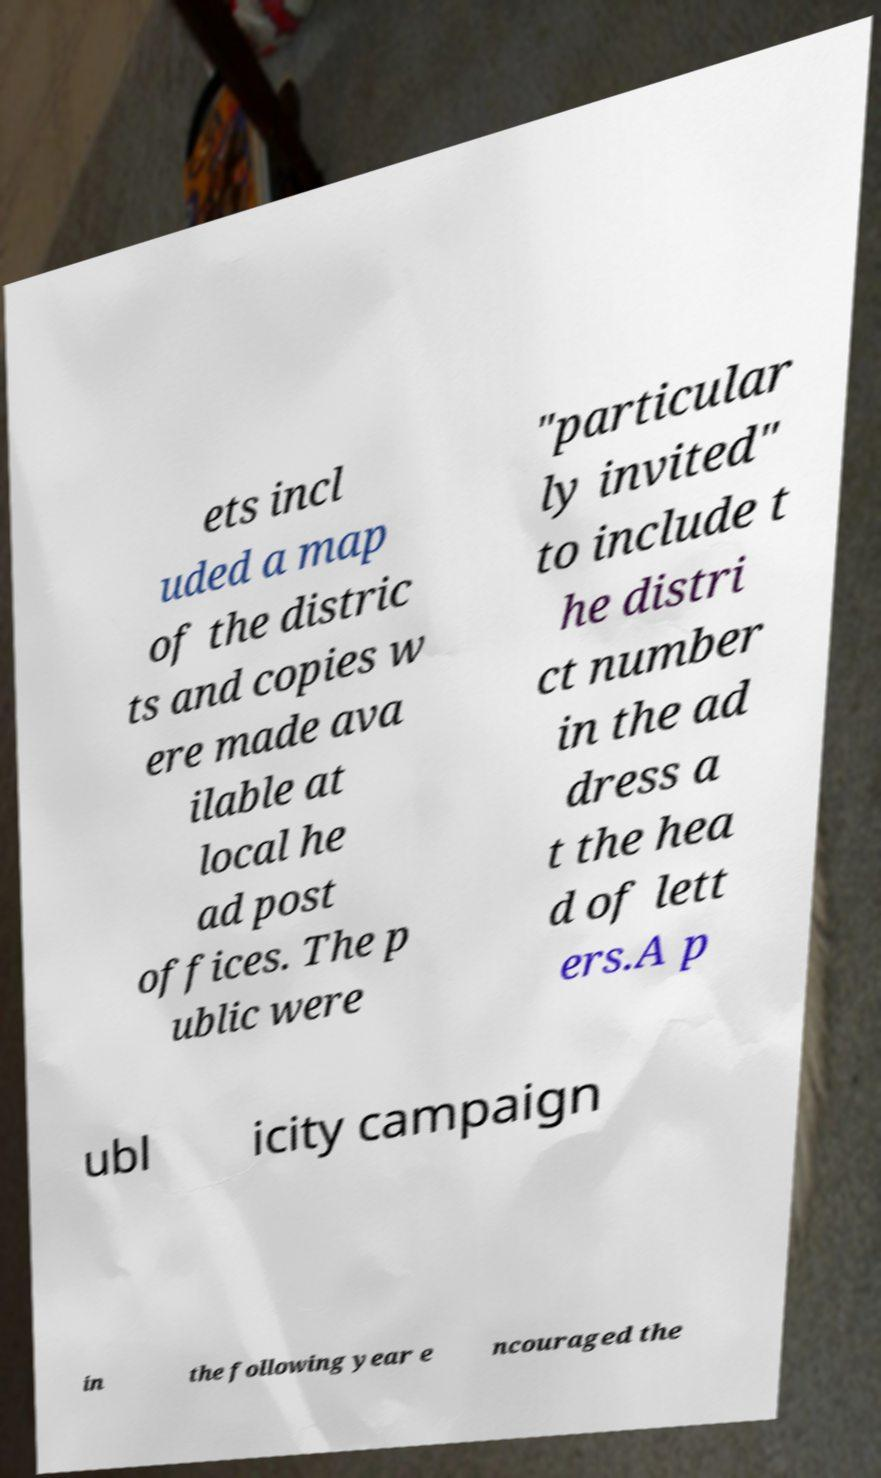There's text embedded in this image that I need extracted. Can you transcribe it verbatim? ets incl uded a map of the distric ts and copies w ere made ava ilable at local he ad post offices. The p ublic were "particular ly invited" to include t he distri ct number in the ad dress a t the hea d of lett ers.A p ubl icity campaign in the following year e ncouraged the 